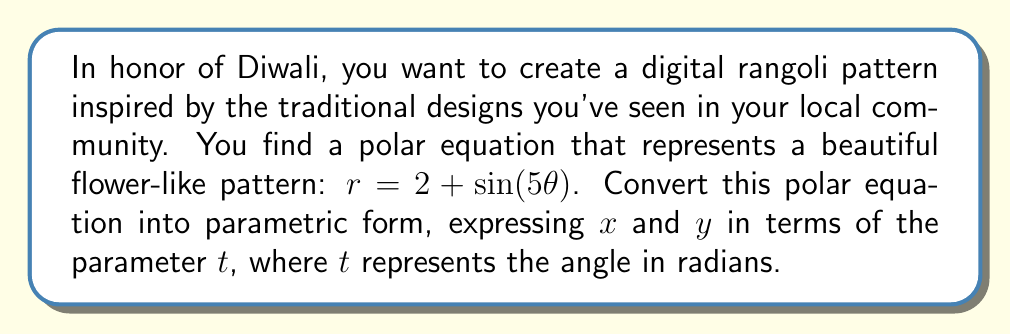Teach me how to tackle this problem. To convert a polar equation into parametric form, we can follow these steps:

1) In polar form, we have $r = 2 + \sin(5\theta)$

2) The general conversion from polar to Cartesian coordinates is:
   $x = r \cos(\theta)$
   $y = r \sin(\theta)$

3) We replace $\theta$ with the parameter $t$:
   $r = 2 + \sin(5t)$

4) Now, we substitute this expression for $r$ into the Cartesian conversion formulas:

   $x = (2 + \sin(5t)) \cos(t)$
   $y = (2 + \sin(5t)) \sin(t)$

5) Expanding these expressions:

   $x = 2\cos(t) + \sin(5t)\cos(t)$
   $y = 2\sin(t) + \sin(5t)\sin(t)$

These equations for $x$ and $y$ in terms of $t$ form the parametric representation of the original polar equation.
Answer: The parametric equations are:

$$x = 2\cos(t) + \sin(5t)\cos(t)$$
$$y = 2\sin(t) + \sin(5t)\sin(t)$$

where $t$ is the parameter representing the angle in radians. 